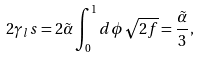Convert formula to latex. <formula><loc_0><loc_0><loc_500><loc_500>2 \gamma _ { l } s = 2 \tilde { \alpha } \int _ { 0 } ^ { 1 } d \phi \sqrt { 2 f } = \frac { \tilde { \alpha } } { 3 } ,</formula> 